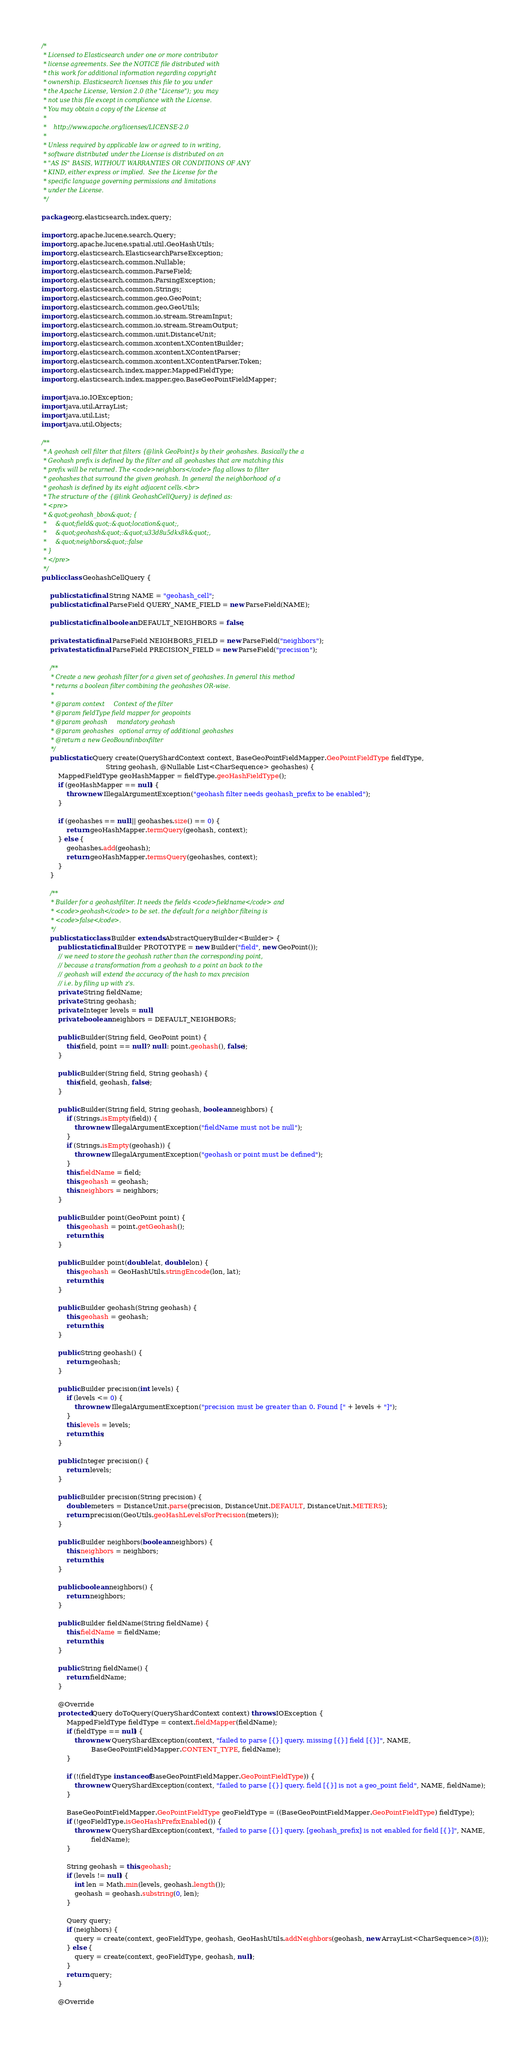Convert code to text. <code><loc_0><loc_0><loc_500><loc_500><_Java_>/*
 * Licensed to Elasticsearch under one or more contributor
 * license agreements. See the NOTICE file distributed with
 * this work for additional information regarding copyright
 * ownership. Elasticsearch licenses this file to you under
 * the Apache License, Version 2.0 (the "License"); you may
 * not use this file except in compliance with the License.
 * You may obtain a copy of the License at
 *
 *    http://www.apache.org/licenses/LICENSE-2.0
 *
 * Unless required by applicable law or agreed to in writing,
 * software distributed under the License is distributed on an
 * "AS IS" BASIS, WITHOUT WARRANTIES OR CONDITIONS OF ANY
 * KIND, either express or implied.  See the License for the
 * specific language governing permissions and limitations
 * under the License.
 */

package org.elasticsearch.index.query;

import org.apache.lucene.search.Query;
import org.apache.lucene.spatial.util.GeoHashUtils;
import org.elasticsearch.ElasticsearchParseException;
import org.elasticsearch.common.Nullable;
import org.elasticsearch.common.ParseField;
import org.elasticsearch.common.ParsingException;
import org.elasticsearch.common.Strings;
import org.elasticsearch.common.geo.GeoPoint;
import org.elasticsearch.common.geo.GeoUtils;
import org.elasticsearch.common.io.stream.StreamInput;
import org.elasticsearch.common.io.stream.StreamOutput;
import org.elasticsearch.common.unit.DistanceUnit;
import org.elasticsearch.common.xcontent.XContentBuilder;
import org.elasticsearch.common.xcontent.XContentParser;
import org.elasticsearch.common.xcontent.XContentParser.Token;
import org.elasticsearch.index.mapper.MappedFieldType;
import org.elasticsearch.index.mapper.geo.BaseGeoPointFieldMapper;

import java.io.IOException;
import java.util.ArrayList;
import java.util.List;
import java.util.Objects;

/**
 * A geohash cell filter that filters {@link GeoPoint}s by their geohashes. Basically the a
 * Geohash prefix is defined by the filter and all geohashes that are matching this
 * prefix will be returned. The <code>neighbors</code> flag allows to filter
 * geohashes that surround the given geohash. In general the neighborhood of a
 * geohash is defined by its eight adjacent cells.<br>
 * The structure of the {@link GeohashCellQuery} is defined as:
 * <pre>
 * &quot;geohash_bbox&quot; {
 *     &quot;field&quot;:&quot;location&quot;,
 *     &quot;geohash&quot;:&quot;u33d8u5dkx8k&quot;,
 *     &quot;neighbors&quot;:false
 * }
 * </pre>
 */
public class GeohashCellQuery {

    public static final String NAME = "geohash_cell";
    public static final ParseField QUERY_NAME_FIELD = new ParseField(NAME);

    public static final boolean DEFAULT_NEIGHBORS = false;

    private static final ParseField NEIGHBORS_FIELD = new ParseField("neighbors");
    private static final ParseField PRECISION_FIELD = new ParseField("precision");

    /**
     * Create a new geohash filter for a given set of geohashes. In general this method
     * returns a boolean filter combining the geohashes OR-wise.
     *
     * @param context     Context of the filter
     * @param fieldType field mapper for geopoints
     * @param geohash     mandatory geohash
     * @param geohashes   optional array of additional geohashes
     * @return a new GeoBoundinboxfilter
     */
    public static Query create(QueryShardContext context, BaseGeoPointFieldMapper.GeoPointFieldType fieldType,
                               String geohash, @Nullable List<CharSequence> geohashes) {
        MappedFieldType geoHashMapper = fieldType.geoHashFieldType();
        if (geoHashMapper == null) {
            throw new IllegalArgumentException("geohash filter needs geohash_prefix to be enabled");
        }

        if (geohashes == null || geohashes.size() == 0) {
            return geoHashMapper.termQuery(geohash, context);
        } else {
            geohashes.add(geohash);
            return geoHashMapper.termsQuery(geohashes, context);
        }
    }

    /**
     * Builder for a geohashfilter. It needs the fields <code>fieldname</code> and
     * <code>geohash</code> to be set. the default for a neighbor filteing is
     * <code>false</code>.
     */
    public static class Builder extends AbstractQueryBuilder<Builder> {
        public static final Builder PROTOTYPE = new Builder("field", new GeoPoint());
        // we need to store the geohash rather than the corresponding point,
        // because a transformation from a geohash to a point an back to the
        // geohash will extend the accuracy of the hash to max precision
        // i.e. by filing up with z's.
        private String fieldName;
        private String geohash;
        private Integer levels = null;
        private boolean neighbors = DEFAULT_NEIGHBORS;

        public Builder(String field, GeoPoint point) {
            this(field, point == null ? null : point.geohash(), false);
        }

        public Builder(String field, String geohash) {
            this(field, geohash, false);
        }

        public Builder(String field, String geohash, boolean neighbors) {
            if (Strings.isEmpty(field)) {
                throw new IllegalArgumentException("fieldName must not be null");
            }
            if (Strings.isEmpty(geohash)) {
                throw new IllegalArgumentException("geohash or point must be defined");
            }
            this.fieldName = field;
            this.geohash = geohash;
            this.neighbors = neighbors;
        }

        public Builder point(GeoPoint point) {
            this.geohash = point.getGeohash();
            return this;
        }

        public Builder point(double lat, double lon) {
            this.geohash = GeoHashUtils.stringEncode(lon, lat);
            return this;
        }

        public Builder geohash(String geohash) {
            this.geohash = geohash;
            return this;
        }

        public String geohash() {
            return geohash;
        }

        public Builder precision(int levels) {
            if (levels <= 0) {
                throw new IllegalArgumentException("precision must be greater than 0. Found [" + levels + "]");
            }
            this.levels = levels;
            return this;
        }

        public Integer precision() {
            return levels;
        }

        public Builder precision(String precision) {
            double meters = DistanceUnit.parse(precision, DistanceUnit.DEFAULT, DistanceUnit.METERS);
            return precision(GeoUtils.geoHashLevelsForPrecision(meters));
        }

        public Builder neighbors(boolean neighbors) {
            this.neighbors = neighbors;
            return this;
        }

        public boolean neighbors() {
            return neighbors;
        }

        public Builder fieldName(String fieldName) {
            this.fieldName = fieldName;
            return this;
        }

        public String fieldName() {
            return fieldName;
        }

        @Override
        protected Query doToQuery(QueryShardContext context) throws IOException {
            MappedFieldType fieldType = context.fieldMapper(fieldName);
            if (fieldType == null) {
                throw new QueryShardException(context, "failed to parse [{}] query. missing [{}] field [{}]", NAME,
                        BaseGeoPointFieldMapper.CONTENT_TYPE, fieldName);
            }

            if (!(fieldType instanceof BaseGeoPointFieldMapper.GeoPointFieldType)) {
                throw new QueryShardException(context, "failed to parse [{}] query. field [{}] is not a geo_point field", NAME, fieldName);
            }

            BaseGeoPointFieldMapper.GeoPointFieldType geoFieldType = ((BaseGeoPointFieldMapper.GeoPointFieldType) fieldType);
            if (!geoFieldType.isGeoHashPrefixEnabled()) {
                throw new QueryShardException(context, "failed to parse [{}] query. [geohash_prefix] is not enabled for field [{}]", NAME,
                        fieldName);
            }

            String geohash = this.geohash;
            if (levels != null) {
                int len = Math.min(levels, geohash.length());
                geohash = geohash.substring(0, len);
            }

            Query query;
            if (neighbors) {
                query = create(context, geoFieldType, geohash, GeoHashUtils.addNeighbors(geohash, new ArrayList<CharSequence>(8)));
            } else {
                query = create(context, geoFieldType, geohash, null);
            }
            return query;
        }

        @Override</code> 